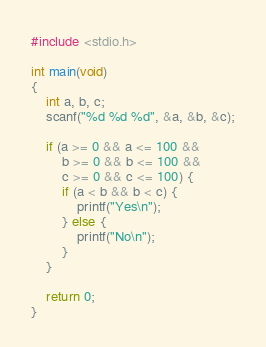Convert code to text. <code><loc_0><loc_0><loc_500><loc_500><_C_>#include <stdio.h>
 
int main(void)
{
    int a, b, c;
    scanf("%d %d %d", &a, &b, &c);
    
    if (a >= 0 && a <= 100 &&
        b >= 0 && b <= 100 &&
        c >= 0 && c <= 100) {
        if (a < b && b < c) {
            printf("Yes\n");
        } else {
            printf("No\n");
        }
    }

    return 0;
}</code> 